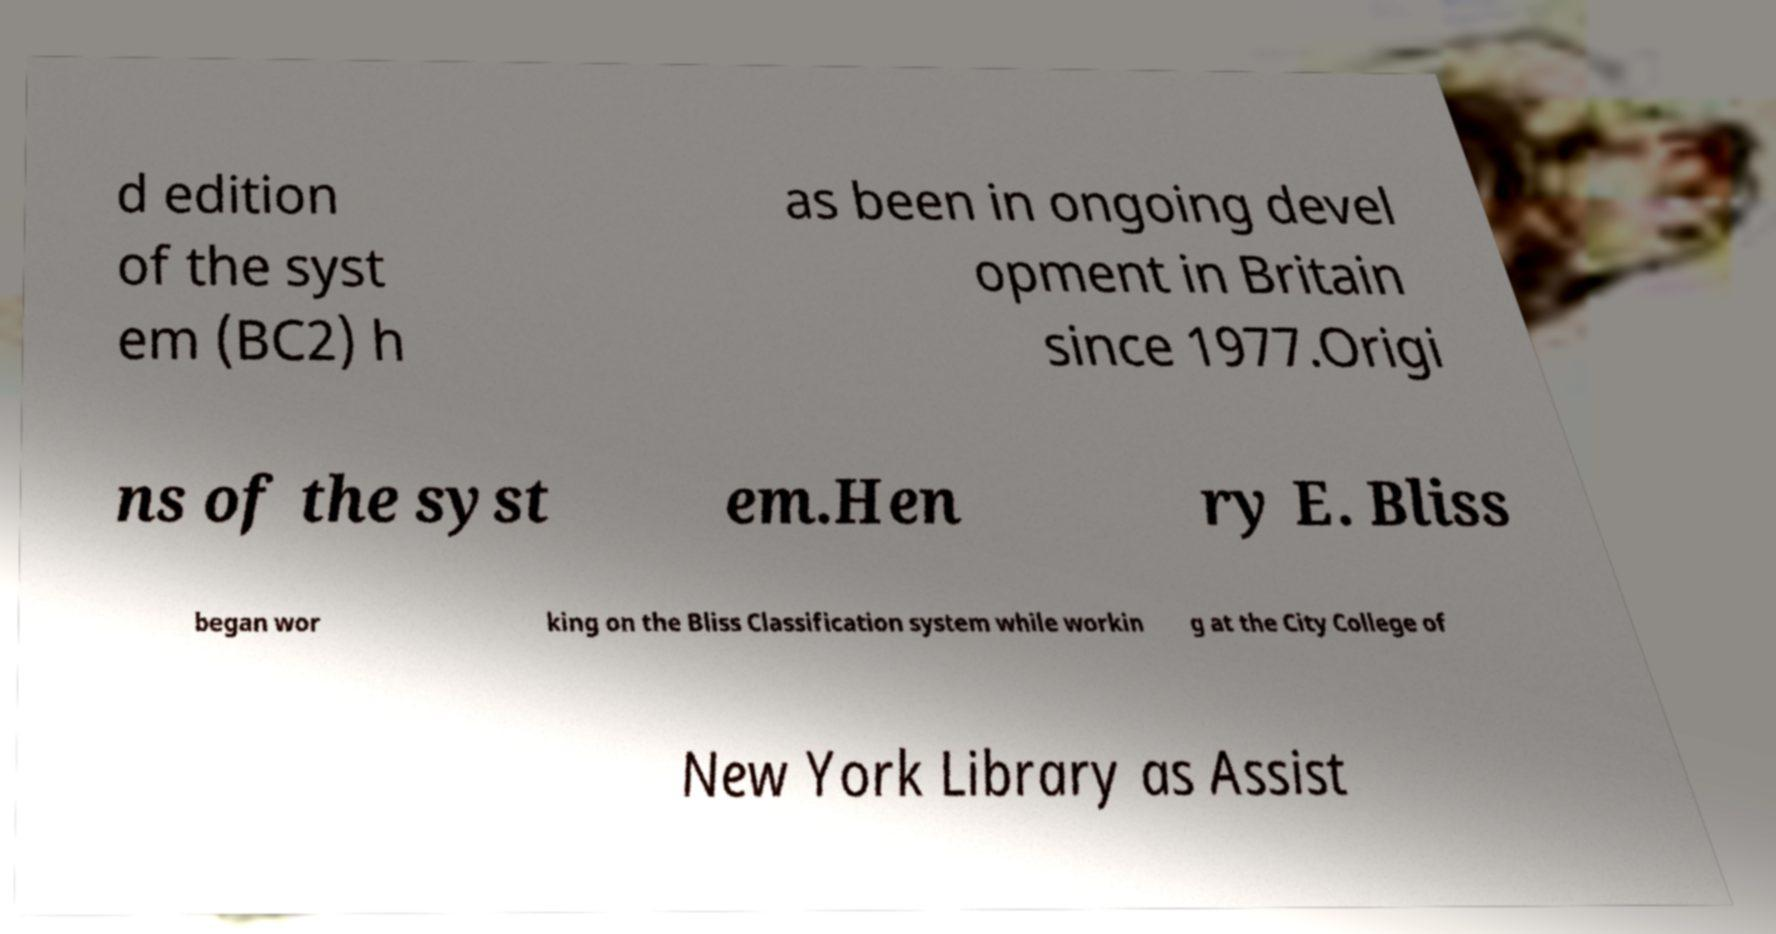What messages or text are displayed in this image? I need them in a readable, typed format. d edition of the syst em (BC2) h as been in ongoing devel opment in Britain since 1977.Origi ns of the syst em.Hen ry E. Bliss began wor king on the Bliss Classification system while workin g at the City College of New York Library as Assist 